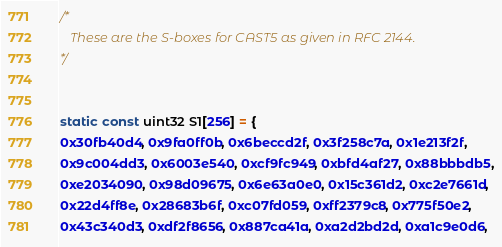<code> <loc_0><loc_0><loc_500><loc_500><_C_>/*
   These are the S-boxes for CAST5 as given in RFC 2144.
*/


static const uint32 S1[256] = {
0x30fb40d4, 0x9fa0ff0b, 0x6beccd2f, 0x3f258c7a, 0x1e213f2f,
0x9c004dd3, 0x6003e540, 0xcf9fc949, 0xbfd4af27, 0x88bbbdb5,
0xe2034090, 0x98d09675, 0x6e63a0e0, 0x15c361d2, 0xc2e7661d,
0x22d4ff8e, 0x28683b6f, 0xc07fd059, 0xff2379c8, 0x775f50e2,
0x43c340d3, 0xdf2f8656, 0x887ca41a, 0xa2d2bd2d, 0xa1c9e0d6,</code> 